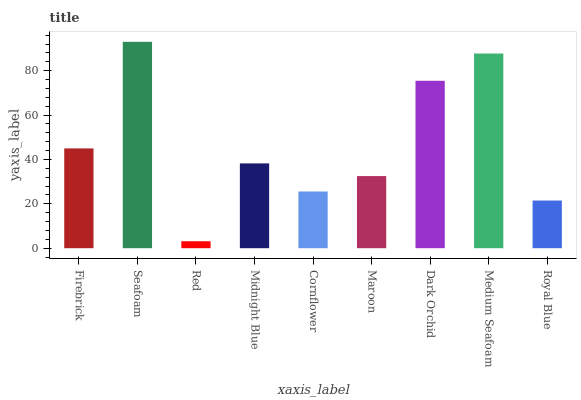Is Red the minimum?
Answer yes or no. Yes. Is Seafoam the maximum?
Answer yes or no. Yes. Is Seafoam the minimum?
Answer yes or no. No. Is Red the maximum?
Answer yes or no. No. Is Seafoam greater than Red?
Answer yes or no. Yes. Is Red less than Seafoam?
Answer yes or no. Yes. Is Red greater than Seafoam?
Answer yes or no. No. Is Seafoam less than Red?
Answer yes or no. No. Is Midnight Blue the high median?
Answer yes or no. Yes. Is Midnight Blue the low median?
Answer yes or no. Yes. Is Medium Seafoam the high median?
Answer yes or no. No. Is Dark Orchid the low median?
Answer yes or no. No. 